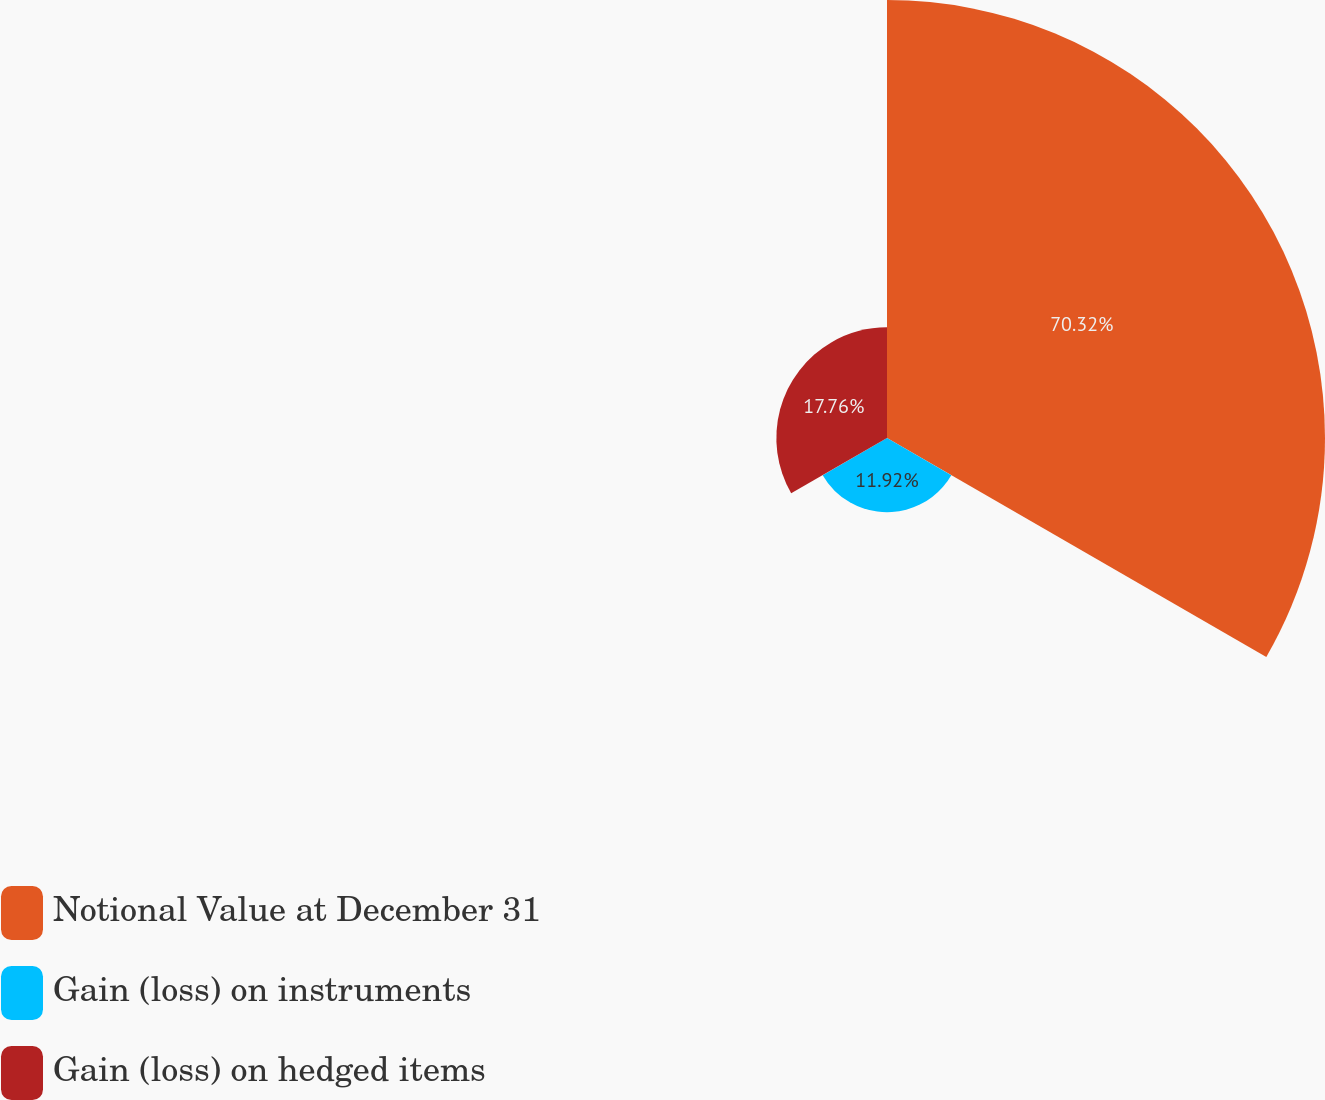Convert chart to OTSL. <chart><loc_0><loc_0><loc_500><loc_500><pie_chart><fcel>Notional Value at December 31<fcel>Gain (loss) on instruments<fcel>Gain (loss) on hedged items<nl><fcel>70.31%<fcel>11.92%<fcel>17.76%<nl></chart> 